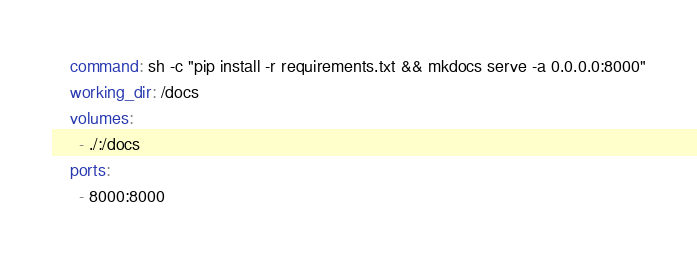Convert code to text. <code><loc_0><loc_0><loc_500><loc_500><_YAML_>    command: sh -c "pip install -r requirements.txt && mkdocs serve -a 0.0.0.0:8000"
    working_dir: /docs
    volumes:
      - ./:/docs
    ports:
      - 8000:8000
</code> 